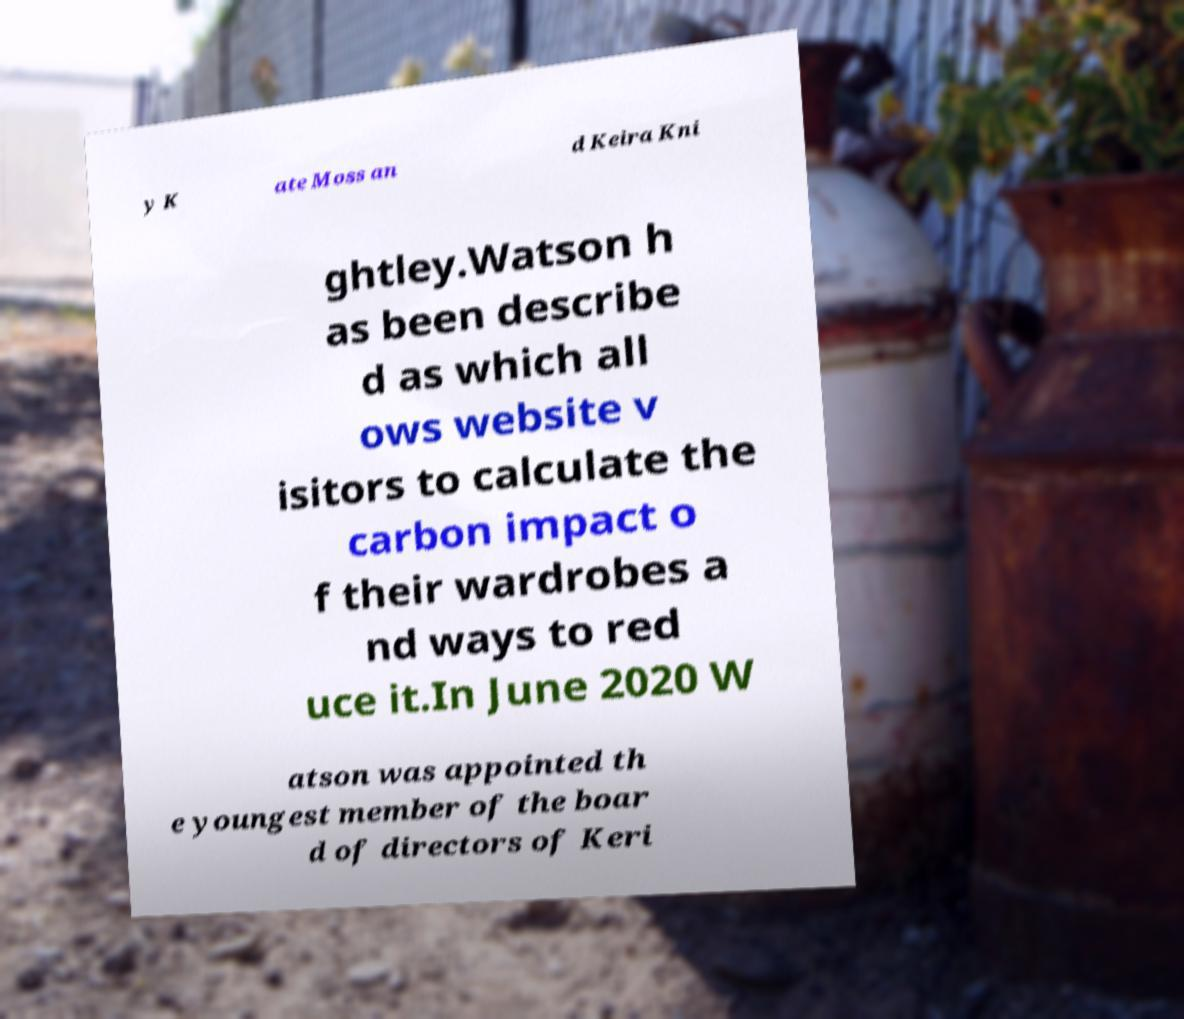What messages or text are displayed in this image? I need them in a readable, typed format. y K ate Moss an d Keira Kni ghtley.Watson h as been describe d as which all ows website v isitors to calculate the carbon impact o f their wardrobes a nd ways to red uce it.In June 2020 W atson was appointed th e youngest member of the boar d of directors of Keri 